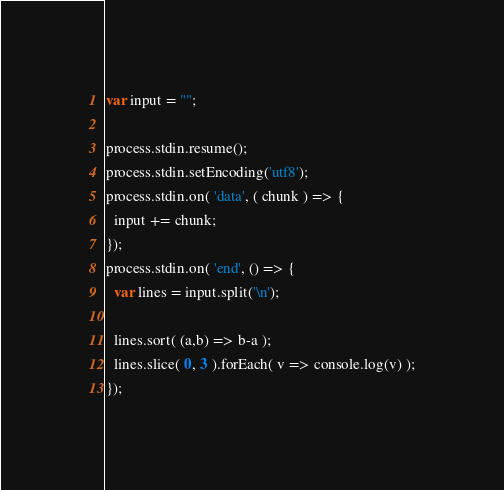Convert code to text. <code><loc_0><loc_0><loc_500><loc_500><_JavaScript_>var input = "";

process.stdin.resume();
process.stdin.setEncoding('utf8');
process.stdin.on( 'data', ( chunk ) => {
  input += chunk;
});
process.stdin.on( 'end', () => {
  var lines = input.split('\n');
  
  lines.sort( (a,b) => b-a );
  lines.slice( 0, 3 ).forEach( v => console.log(v) );
});</code> 